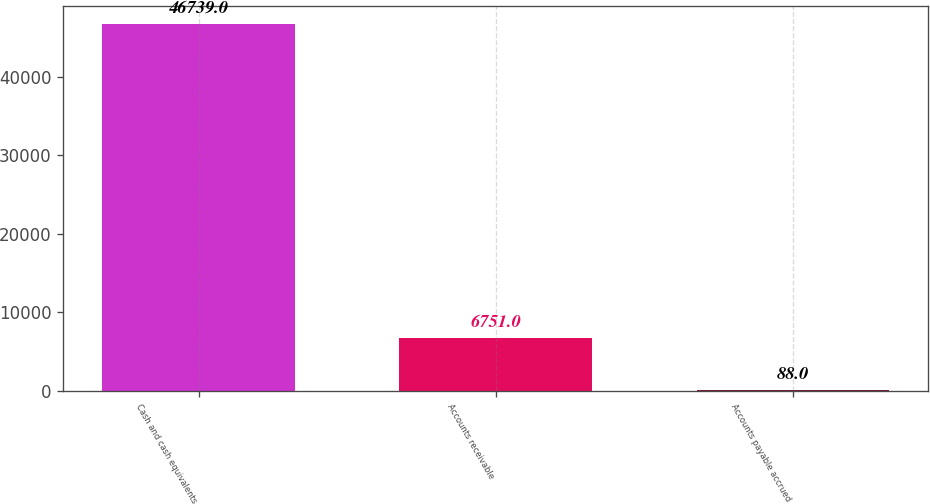Convert chart to OTSL. <chart><loc_0><loc_0><loc_500><loc_500><bar_chart><fcel>Cash and cash equivalents<fcel>Accounts receivable<fcel>Accounts payable accrued<nl><fcel>46739<fcel>6751<fcel>88<nl></chart> 